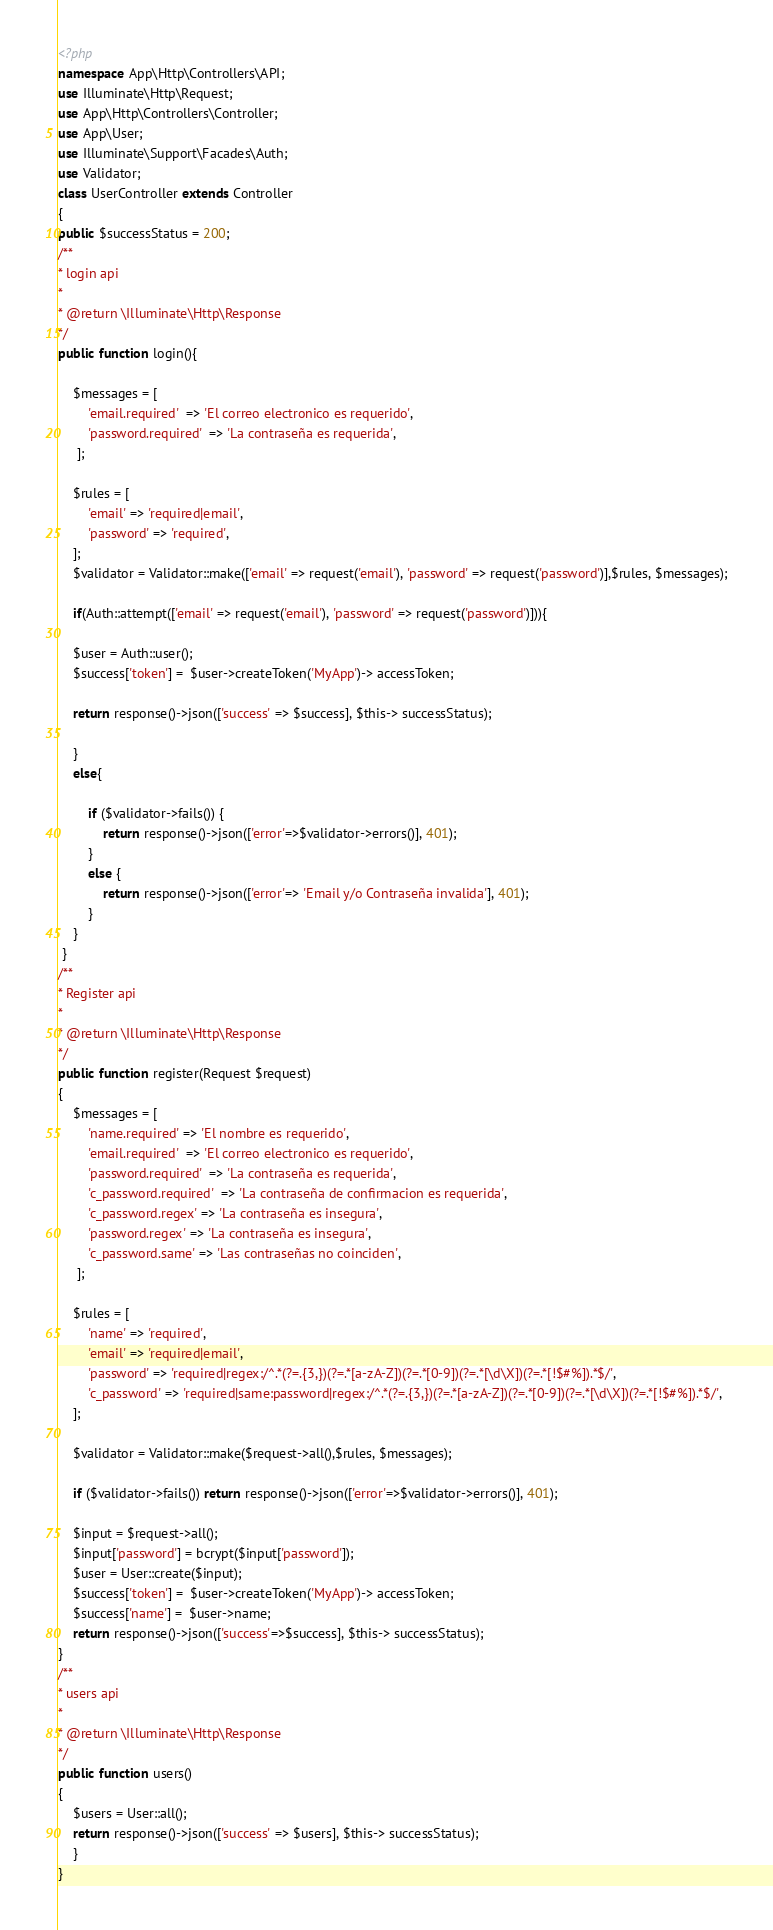Convert code to text. <code><loc_0><loc_0><loc_500><loc_500><_PHP_><?php
namespace App\Http\Controllers\API;
use Illuminate\Http\Request; 
use App\Http\Controllers\Controller; 
use App\User; 
use Illuminate\Support\Facades\Auth; 
use Validator;
class UserController extends Controller 
{
public $successStatus = 200;
/** 
* login api 
* 
* @return \Illuminate\Http\Response 
*/ 
public function login(){ 

    $messages = [
        'email.required'  => 'El correo electronico es requerido',
        'password.required'  => 'La contraseña es requerida',
     ];

    $rules = [ 
        'email' => 'required|email',
        'password' => 'required', 
    ];
    $validator = Validator::make(['email' => request('email'), 'password' => request('password')],$rules, $messages);

    if(Auth::attempt(['email' => request('email'), 'password' => request('password')])){ 

    $user = Auth::user(); 
    $success['token'] =  $user->createToken('MyApp')-> accessToken; 

    return response()->json(['success' => $success], $this-> successStatus); 

    } 
    else{ 
    
        if ($validator->fails()) {
            return response()->json(['error'=>$validator->errors()], 401);
        }
        else {
            return response()->json(['error'=> 'Email y/o Contraseña invalida'], 401);
        }
    } 
 }
/** 
* Register api 
* 
* @return \Illuminate\Http\Response 
*/ 
public function register(Request $request) 
{ 
    $messages = [
        'name.required' => 'El nombre es requerido',
        'email.required'  => 'El correo electronico es requerido',
        'password.required'  => 'La contraseña es requerida',
        'c_password.required'  => 'La contraseña de confirmacion es requerida',
        'c_password.regex' => 'La contraseña es insegura',
        'password.regex' => 'La contraseña es insegura',
        'c_password.same' => 'Las contraseñas no coinciden',
     ];

    $rules = [ 
        'name' => 'required', 
        'email' => 'required|email', 
        'password' => 'required|regex:/^.*(?=.{3,})(?=.*[a-zA-Z])(?=.*[0-9])(?=.*[\d\X])(?=.*[!$#%]).*$/', 
        'c_password' => 'required|same:password|regex:/^.*(?=.{3,})(?=.*[a-zA-Z])(?=.*[0-9])(?=.*[\d\X])(?=.*[!$#%]).*$/', 
    ];

    $validator = Validator::make($request->all(),$rules, $messages);
    
    if ($validator->fails()) return response()->json(['error'=>$validator->errors()], 401);            
    
    $input = $request->all(); 
    $input['password'] = bcrypt($input['password']); 
    $user = User::create($input); 
    $success['token'] =  $user->createToken('MyApp')-> accessToken; 
    $success['name'] =  $user->name;
    return response()->json(['success'=>$success], $this-> successStatus); 
}
/** 
* users api 
* 
* @return \Illuminate\Http\Response 
*/ 
public function users() 
{ 
    $users = User::all();
    return response()->json(['success' => $users], $this-> successStatus); 
    } 
}</code> 